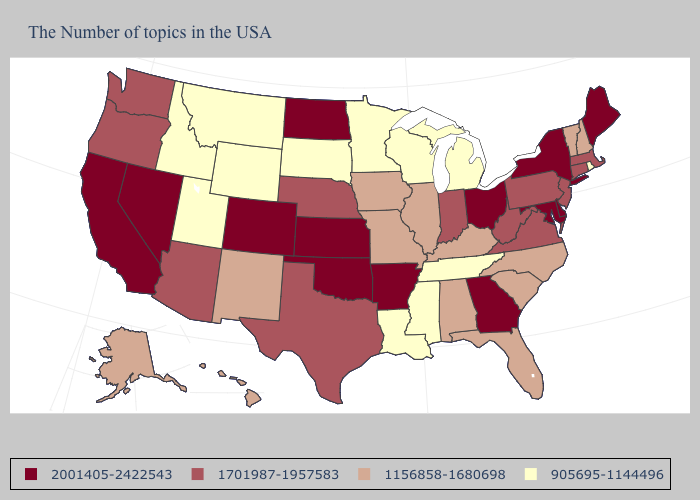Which states hav the highest value in the West?
Quick response, please. Colorado, Nevada, California. Does Montana have the lowest value in the West?
Quick response, please. Yes. What is the value of Michigan?
Write a very short answer. 905695-1144496. What is the value of New Jersey?
Answer briefly. 1701987-1957583. What is the value of Rhode Island?
Keep it brief. 905695-1144496. Among the states that border Wyoming , which have the lowest value?
Write a very short answer. South Dakota, Utah, Montana, Idaho. Which states have the lowest value in the USA?
Quick response, please. Rhode Island, Michigan, Tennessee, Wisconsin, Mississippi, Louisiana, Minnesota, South Dakota, Wyoming, Utah, Montana, Idaho. What is the highest value in states that border West Virginia?
Answer briefly. 2001405-2422543. What is the value of Kansas?
Write a very short answer. 2001405-2422543. What is the value of Virginia?
Answer briefly. 1701987-1957583. Which states hav the highest value in the South?
Give a very brief answer. Delaware, Maryland, Georgia, Arkansas, Oklahoma. Does South Carolina have a lower value than New Jersey?
Answer briefly. Yes. What is the value of Mississippi?
Write a very short answer. 905695-1144496. What is the value of Arizona?
Keep it brief. 1701987-1957583. What is the value of Kentucky?
Give a very brief answer. 1156858-1680698. 